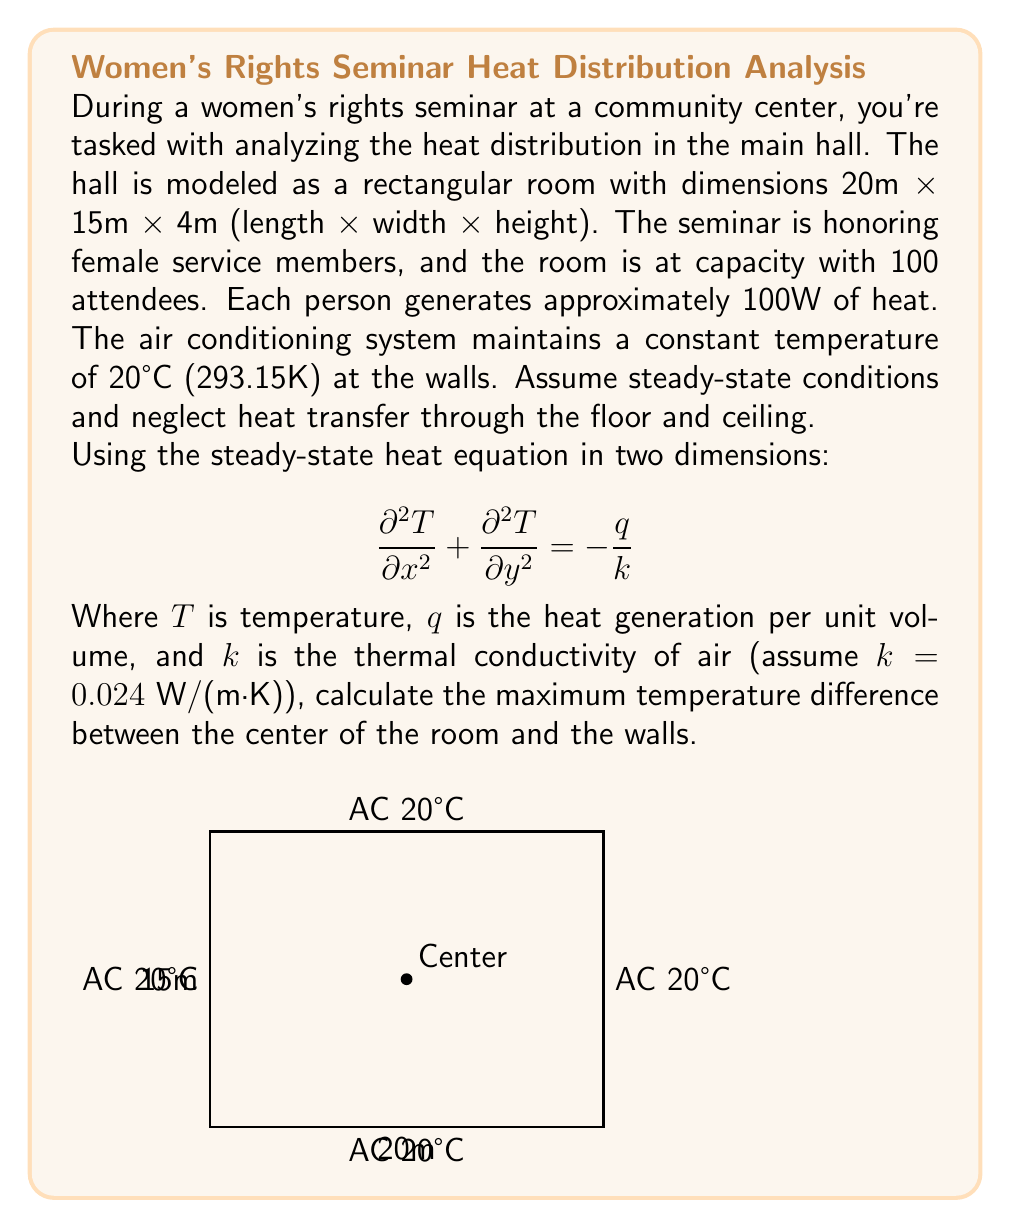Show me your answer to this math problem. Let's approach this problem step-by-step:

1) First, we need to calculate the total heat generation in the room:
   $Q_{total} = 100 \text{ people} \times 100 \text{ W/person} = 10,000 \text{ W}$

2) The volume of the room is:
   $V = 20 \text{ m} \times 15 \text{ m} \times 4 \text{ m} = 1,200 \text{ m}^3$

3) The heat generation per unit volume is:
   $q = \frac{Q_{total}}{V} = \frac{10,000 \text{ W}}{1,200 \text{ m}^3} = 8.33 \text{ W/m}^3$

4) For a rectangular room with uniform heat generation, the temperature distribution is given by:

   $$T(x,y) = T_w + \frac{q}{2k}\left(\frac{L_x^2}{4} - x^2 + \frac{L_y^2}{4} - y^2\right)$$

   Where $T_w$ is the wall temperature, $L_x$ and $L_y$ are the room dimensions.

5) The maximum temperature will be at the center of the room $(x=10, y=7.5)$:

   $$T_{max} = T_w + \frac{q}{2k}\left(\frac{20^2}{4} + \frac{15^2}{4}\right)$$

6) Substituting the values:

   $$T_{max} = 293.15 + \frac{8.33}{2(0.024)}\left(\frac{400}{4} + \frac{225}{4}\right)$$

7) Simplifying:

   $$T_{max} = 293.15 + 173.54 \times 156.25 = 293.15 + 27.12 = 320.27 \text{ K}$$

8) The temperature difference is:

   $$\Delta T = T_{max} - T_w = 320.27 - 293.15 = 27.12 \text{ K}$$
Answer: 27.12 K 